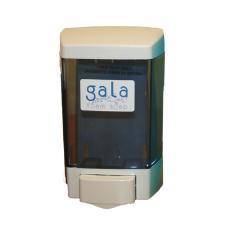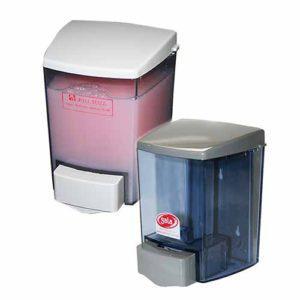The first image is the image on the left, the second image is the image on the right. For the images shown, is this caption "There are more than two dispensers." true? Answer yes or no. Yes. The first image is the image on the left, the second image is the image on the right. Given the left and right images, does the statement "There are exactly three visible containers of soap, two in one image and one in the other." hold true? Answer yes or no. Yes. 